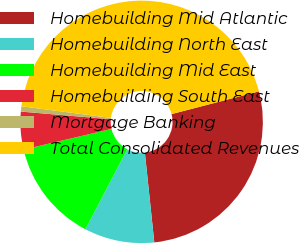Convert chart to OTSL. <chart><loc_0><loc_0><loc_500><loc_500><pie_chart><fcel>Homebuilding Mid Atlantic<fcel>Homebuilding North East<fcel>Homebuilding Mid East<fcel>Homebuilding South East<fcel>Mortgage Banking<fcel>Total Consolidated Revenues<nl><fcel>27.38%<fcel>9.34%<fcel>13.66%<fcel>5.02%<fcel>0.7%<fcel>43.9%<nl></chart> 